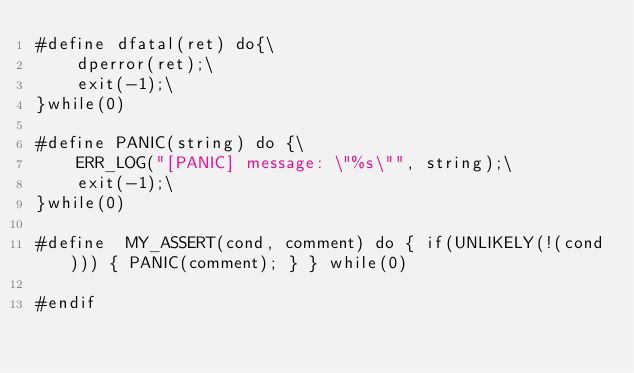Convert code to text. <code><loc_0><loc_0><loc_500><loc_500><_C_>#define dfatal(ret) do{\
    dperror(ret);\
    exit(-1);\
}while(0)

#define PANIC(string) do {\
    ERR_LOG("[PANIC] message: \"%s\"", string);\
    exit(-1);\
}while(0)

#define  MY_ASSERT(cond, comment) do { if(UNLIKELY(!(cond))) { PANIC(comment); } } while(0)

#endif
</code> 